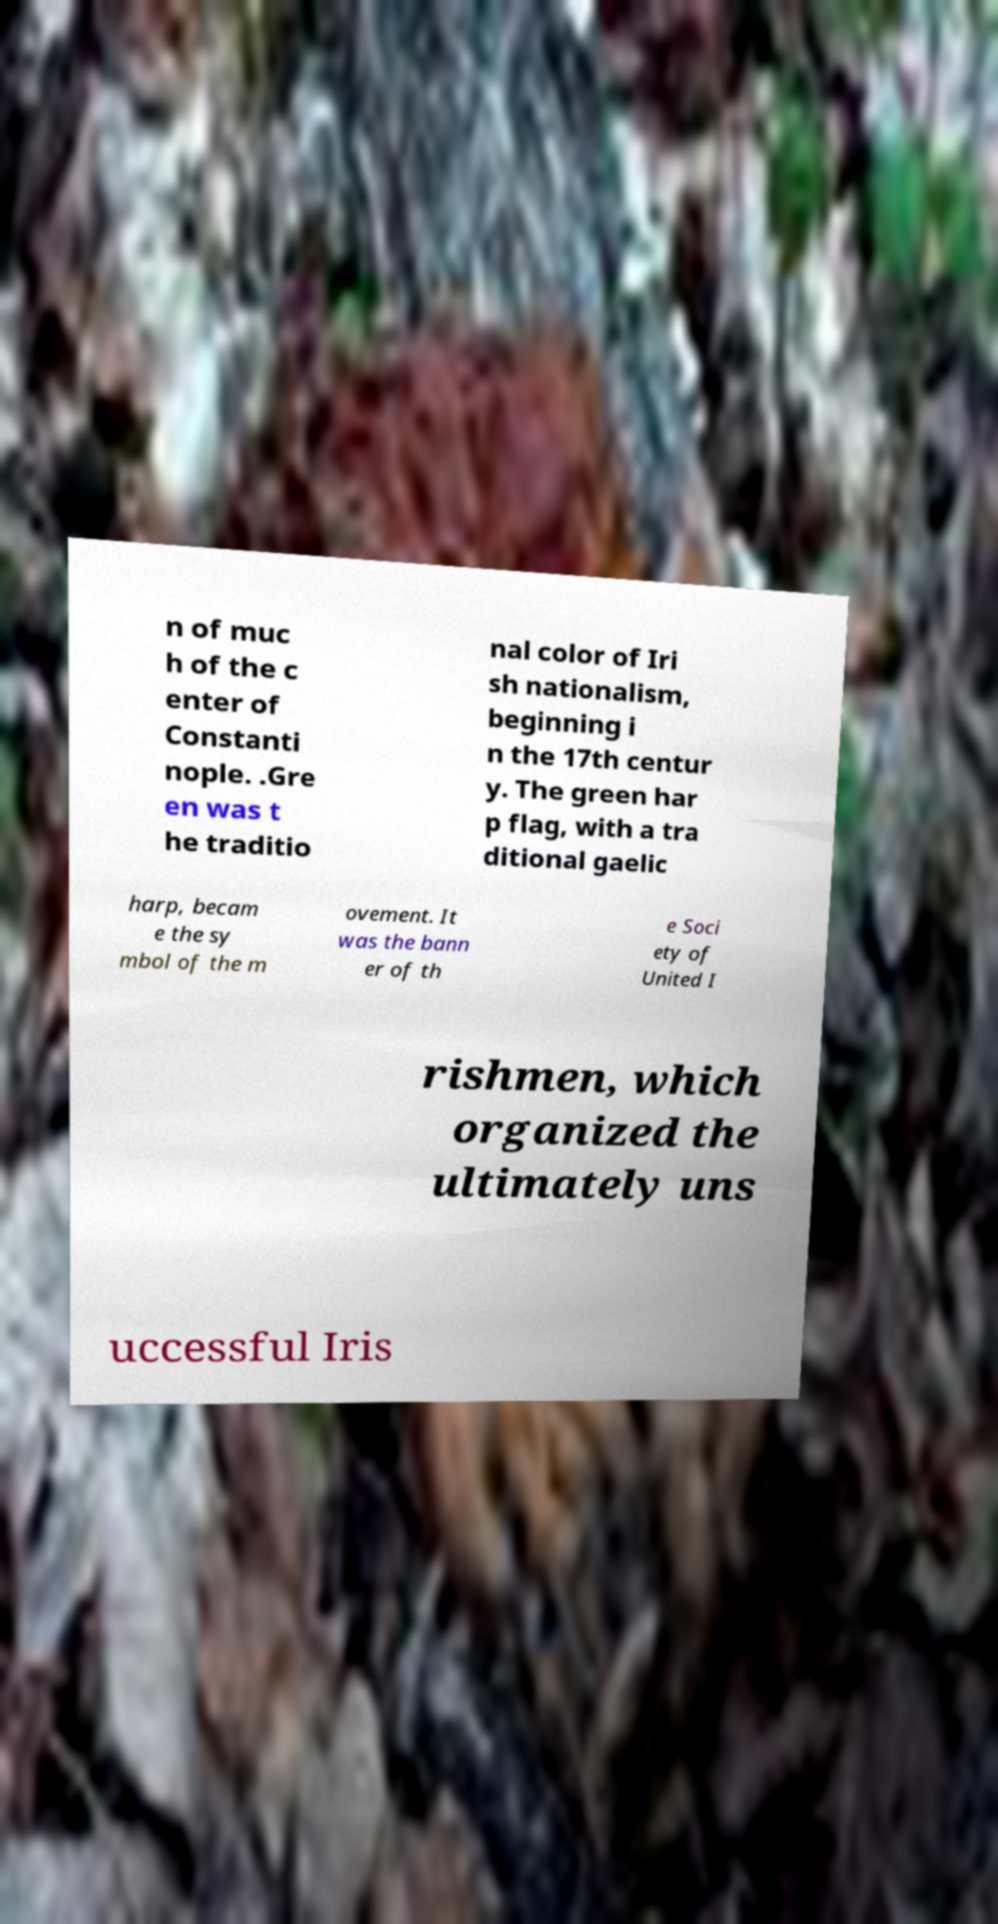Please read and relay the text visible in this image. What does it say? n of muc h of the c enter of Constanti nople. .Gre en was t he traditio nal color of Iri sh nationalism, beginning i n the 17th centur y. The green har p flag, with a tra ditional gaelic harp, becam e the sy mbol of the m ovement. It was the bann er of th e Soci ety of United I rishmen, which organized the ultimately uns uccessful Iris 